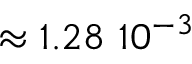Convert formula to latex. <formula><loc_0><loc_0><loc_500><loc_500>\approx 1 . 2 8 1 0 ^ { - 3 }</formula> 